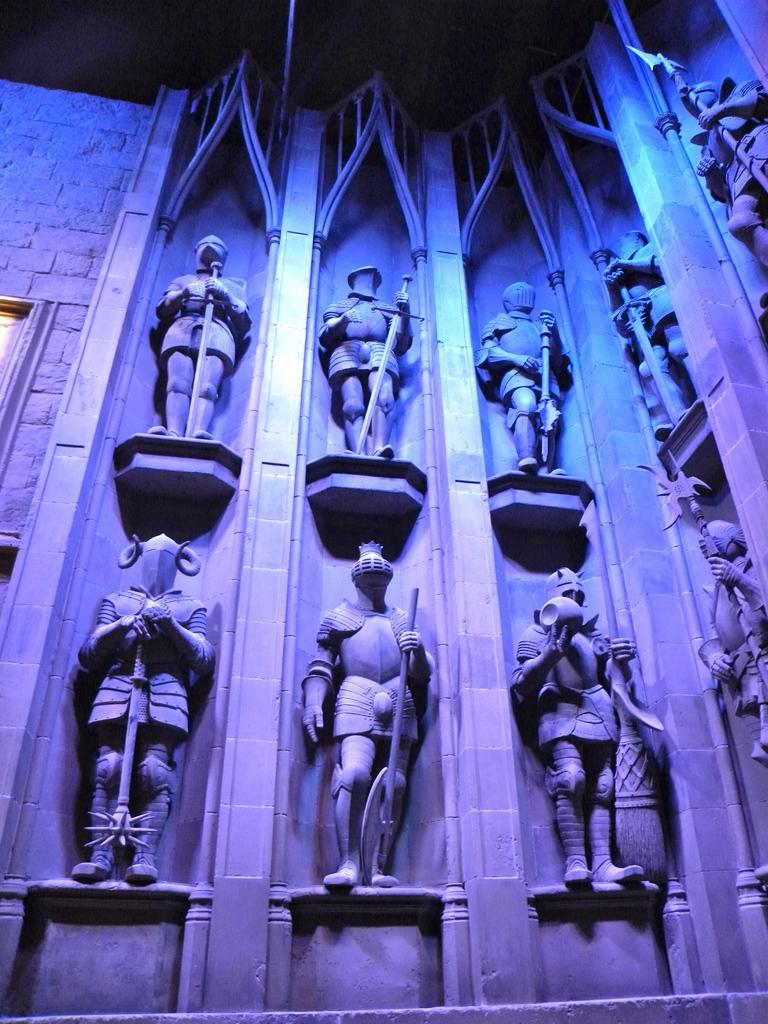In one or two sentences, can you explain what this image depicts? In the picture I can see statues, I can see stone wall and I can see blue and pink color lights. 